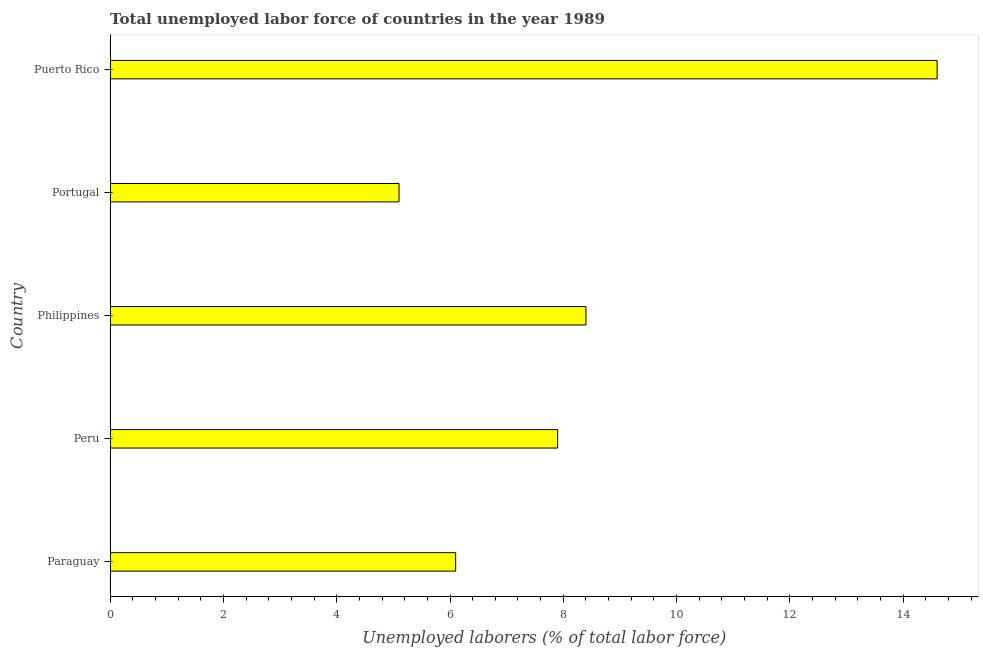Does the graph contain any zero values?
Keep it short and to the point. No. What is the title of the graph?
Your answer should be compact. Total unemployed labor force of countries in the year 1989. What is the label or title of the X-axis?
Keep it short and to the point. Unemployed laborers (% of total labor force). What is the total unemployed labour force in Peru?
Provide a short and direct response. 7.9. Across all countries, what is the maximum total unemployed labour force?
Make the answer very short. 14.6. Across all countries, what is the minimum total unemployed labour force?
Give a very brief answer. 5.1. In which country was the total unemployed labour force maximum?
Provide a succinct answer. Puerto Rico. In which country was the total unemployed labour force minimum?
Your response must be concise. Portugal. What is the sum of the total unemployed labour force?
Ensure brevity in your answer.  42.1. What is the average total unemployed labour force per country?
Your answer should be compact. 8.42. What is the median total unemployed labour force?
Offer a terse response. 7.9. In how many countries, is the total unemployed labour force greater than 6.4 %?
Give a very brief answer. 3. What is the ratio of the total unemployed labour force in Philippines to that in Portugal?
Keep it short and to the point. 1.65. Is the total unemployed labour force in Paraguay less than that in Peru?
Give a very brief answer. Yes. What is the difference between the highest and the second highest total unemployed labour force?
Give a very brief answer. 6.2. Is the sum of the total unemployed labour force in Philippines and Portugal greater than the maximum total unemployed labour force across all countries?
Offer a terse response. No. How many bars are there?
Your answer should be compact. 5. How many countries are there in the graph?
Keep it short and to the point. 5. What is the Unemployed laborers (% of total labor force) in Paraguay?
Your response must be concise. 6.1. What is the Unemployed laborers (% of total labor force) of Peru?
Your answer should be compact. 7.9. What is the Unemployed laborers (% of total labor force) in Philippines?
Make the answer very short. 8.4. What is the Unemployed laborers (% of total labor force) of Portugal?
Provide a succinct answer. 5.1. What is the Unemployed laborers (% of total labor force) of Puerto Rico?
Your answer should be very brief. 14.6. What is the difference between the Unemployed laborers (% of total labor force) in Paraguay and Philippines?
Your answer should be compact. -2.3. What is the difference between the Unemployed laborers (% of total labor force) in Peru and Portugal?
Give a very brief answer. 2.8. What is the difference between the Unemployed laborers (% of total labor force) in Philippines and Portugal?
Provide a short and direct response. 3.3. What is the difference between the Unemployed laborers (% of total labor force) in Philippines and Puerto Rico?
Your answer should be very brief. -6.2. What is the ratio of the Unemployed laborers (% of total labor force) in Paraguay to that in Peru?
Provide a succinct answer. 0.77. What is the ratio of the Unemployed laborers (% of total labor force) in Paraguay to that in Philippines?
Keep it short and to the point. 0.73. What is the ratio of the Unemployed laborers (% of total labor force) in Paraguay to that in Portugal?
Make the answer very short. 1.2. What is the ratio of the Unemployed laborers (% of total labor force) in Paraguay to that in Puerto Rico?
Keep it short and to the point. 0.42. What is the ratio of the Unemployed laborers (% of total labor force) in Peru to that in Portugal?
Make the answer very short. 1.55. What is the ratio of the Unemployed laborers (% of total labor force) in Peru to that in Puerto Rico?
Your answer should be very brief. 0.54. What is the ratio of the Unemployed laborers (% of total labor force) in Philippines to that in Portugal?
Provide a succinct answer. 1.65. What is the ratio of the Unemployed laborers (% of total labor force) in Philippines to that in Puerto Rico?
Your response must be concise. 0.57. What is the ratio of the Unemployed laborers (% of total labor force) in Portugal to that in Puerto Rico?
Give a very brief answer. 0.35. 